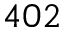<formula> <loc_0><loc_0><loc_500><loc_500>4 0 2</formula> 